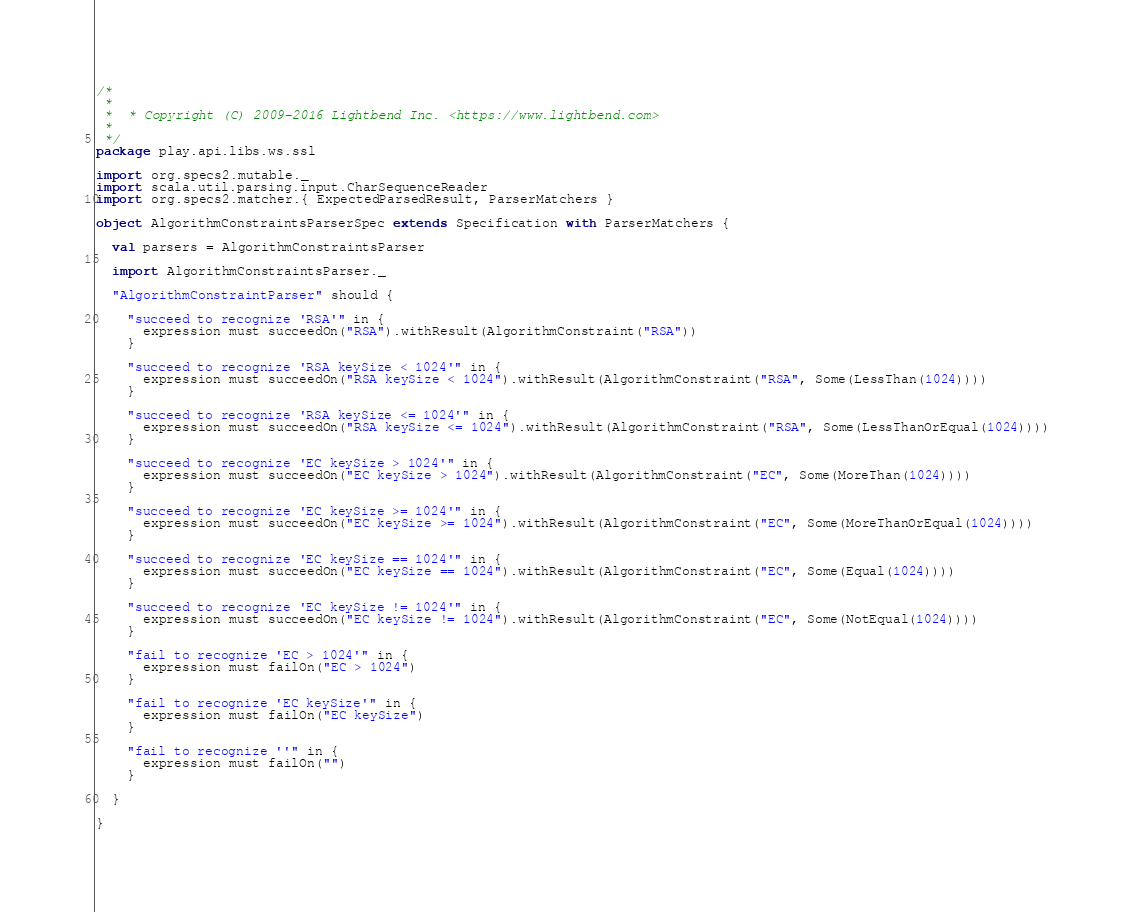Convert code to text. <code><loc_0><loc_0><loc_500><loc_500><_Scala_>/*
 *
 *  * Copyright (C) 2009-2016 Lightbend Inc. <https://www.lightbend.com>
 *
 */
package play.api.libs.ws.ssl

import org.specs2.mutable._
import scala.util.parsing.input.CharSequenceReader
import org.specs2.matcher.{ ExpectedParsedResult, ParserMatchers }

object AlgorithmConstraintsParserSpec extends Specification with ParserMatchers {

  val parsers = AlgorithmConstraintsParser

  import AlgorithmConstraintsParser._

  "AlgorithmConstraintParser" should {

    "succeed to recognize 'RSA'" in {
      expression must succeedOn("RSA").withResult(AlgorithmConstraint("RSA"))
    }

    "succeed to recognize 'RSA keySize < 1024'" in {
      expression must succeedOn("RSA keySize < 1024").withResult(AlgorithmConstraint("RSA", Some(LessThan(1024))))
    }

    "succeed to recognize 'RSA keySize <= 1024'" in {
      expression must succeedOn("RSA keySize <= 1024").withResult(AlgorithmConstraint("RSA", Some(LessThanOrEqual(1024))))
    }

    "succeed to recognize 'EC keySize > 1024'" in {
      expression must succeedOn("EC keySize > 1024").withResult(AlgorithmConstraint("EC", Some(MoreThan(1024))))
    }

    "succeed to recognize 'EC keySize >= 1024'" in {
      expression must succeedOn("EC keySize >= 1024").withResult(AlgorithmConstraint("EC", Some(MoreThanOrEqual(1024))))
    }

    "succeed to recognize 'EC keySize == 1024'" in {
      expression must succeedOn("EC keySize == 1024").withResult(AlgorithmConstraint("EC", Some(Equal(1024))))
    }

    "succeed to recognize 'EC keySize != 1024'" in {
      expression must succeedOn("EC keySize != 1024").withResult(AlgorithmConstraint("EC", Some(NotEqual(1024))))
    }

    "fail to recognize 'EC > 1024'" in {
      expression must failOn("EC > 1024")
    }

    "fail to recognize 'EC keySize'" in {
      expression must failOn("EC keySize")
    }

    "fail to recognize ''" in {
      expression must failOn("")
    }

  }

}
</code> 